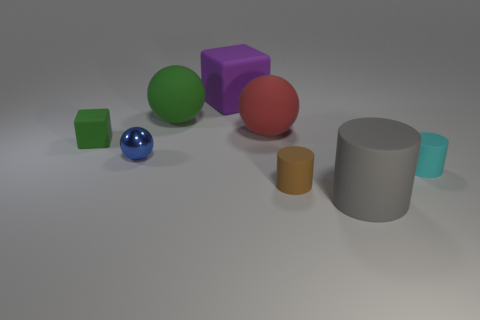Subtract all big spheres. How many spheres are left? 1 Add 1 brown rubber objects. How many objects exist? 9 Subtract all purple cubes. How many cubes are left? 1 Subtract 1 spheres. How many spheres are left? 2 Subtract all big gray matte objects. Subtract all large cubes. How many objects are left? 6 Add 8 brown things. How many brown things are left? 9 Add 6 big brown rubber blocks. How many big brown rubber blocks exist? 6 Subtract 0 brown blocks. How many objects are left? 8 Subtract all cubes. How many objects are left? 6 Subtract all green cylinders. Subtract all gray blocks. How many cylinders are left? 3 